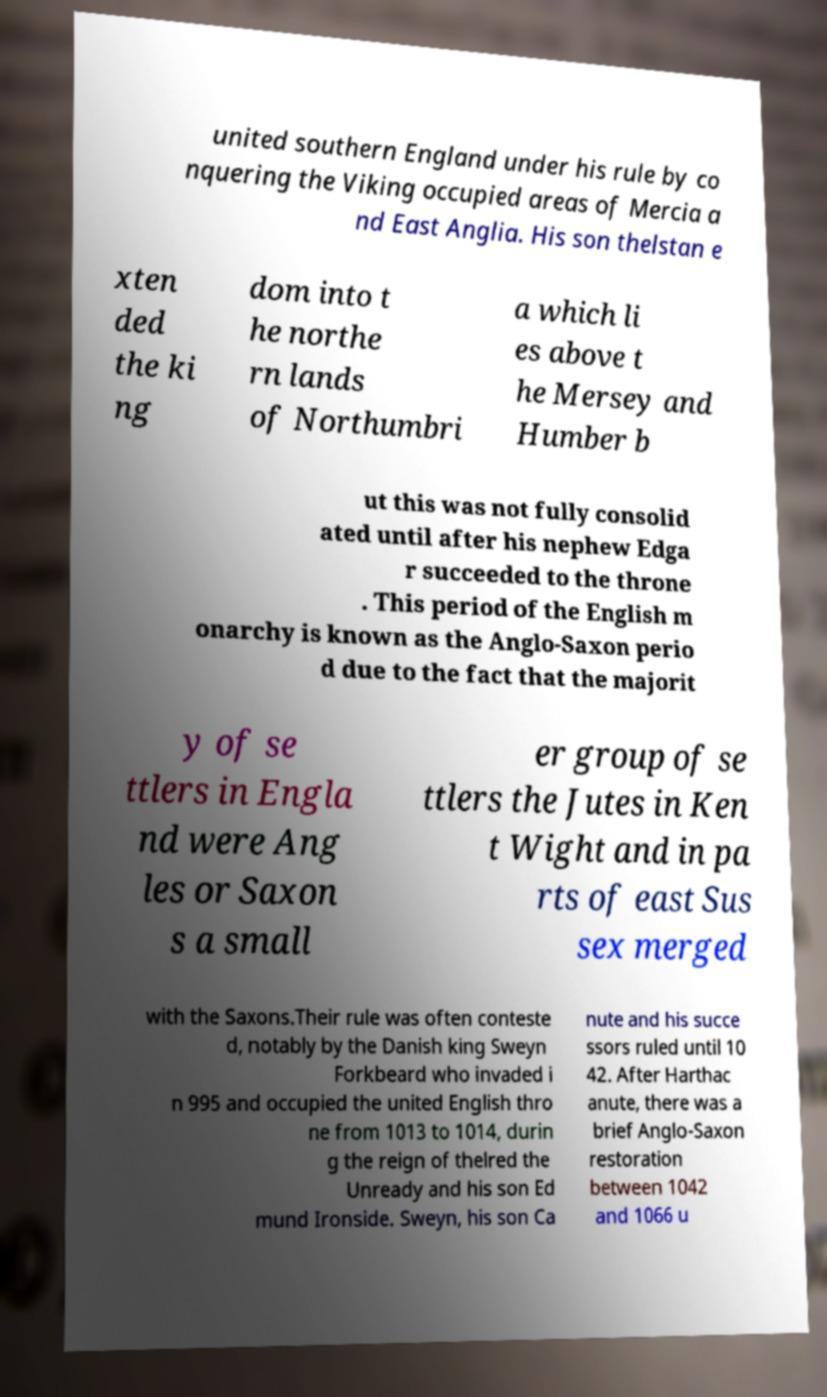Can you accurately transcribe the text from the provided image for me? united southern England under his rule by co nquering the Viking occupied areas of Mercia a nd East Anglia. His son thelstan e xten ded the ki ng dom into t he northe rn lands of Northumbri a which li es above t he Mersey and Humber b ut this was not fully consolid ated until after his nephew Edga r succeeded to the throne . This period of the English m onarchy is known as the Anglo-Saxon perio d due to the fact that the majorit y of se ttlers in Engla nd were Ang les or Saxon s a small er group of se ttlers the Jutes in Ken t Wight and in pa rts of east Sus sex merged with the Saxons.Their rule was often conteste d, notably by the Danish king Sweyn Forkbeard who invaded i n 995 and occupied the united English thro ne from 1013 to 1014, durin g the reign of thelred the Unready and his son Ed mund Ironside. Sweyn, his son Ca nute and his succe ssors ruled until 10 42. After Harthac anute, there was a brief Anglo-Saxon restoration between 1042 and 1066 u 